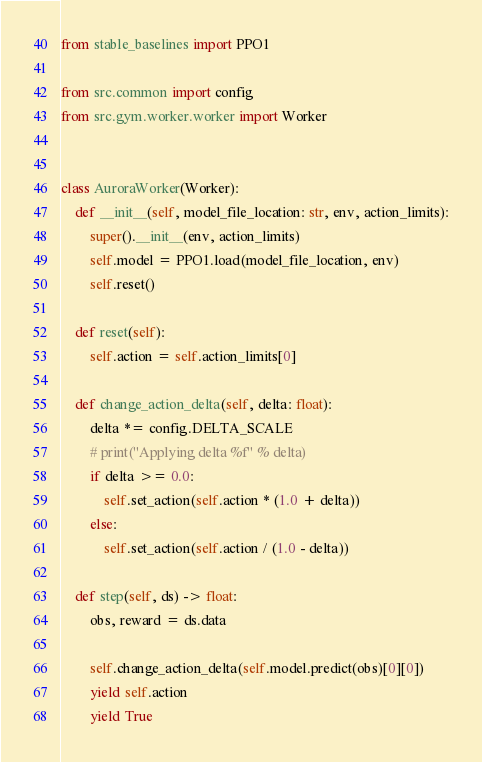<code> <loc_0><loc_0><loc_500><loc_500><_Python_>from stable_baselines import PPO1

from src.common import config
from src.gym.worker.worker import Worker


class AuroraWorker(Worker):
    def __init__(self, model_file_location: str, env, action_limits):
        super().__init__(env, action_limits)
        self.model = PPO1.load(model_file_location, env)
        self.reset()

    def reset(self):
        self.action = self.action_limits[0]

    def change_action_delta(self, delta: float):
        delta *= config.DELTA_SCALE
        # print("Applying delta %f" % delta)
        if delta >= 0.0:
            self.set_action(self.action * (1.0 + delta))
        else:
            self.set_action(self.action / (1.0 - delta))

    def step(self, ds) -> float:
        obs, reward = ds.data

        self.change_action_delta(self.model.predict(obs)[0][0])
        yield self.action
        yield True
</code> 